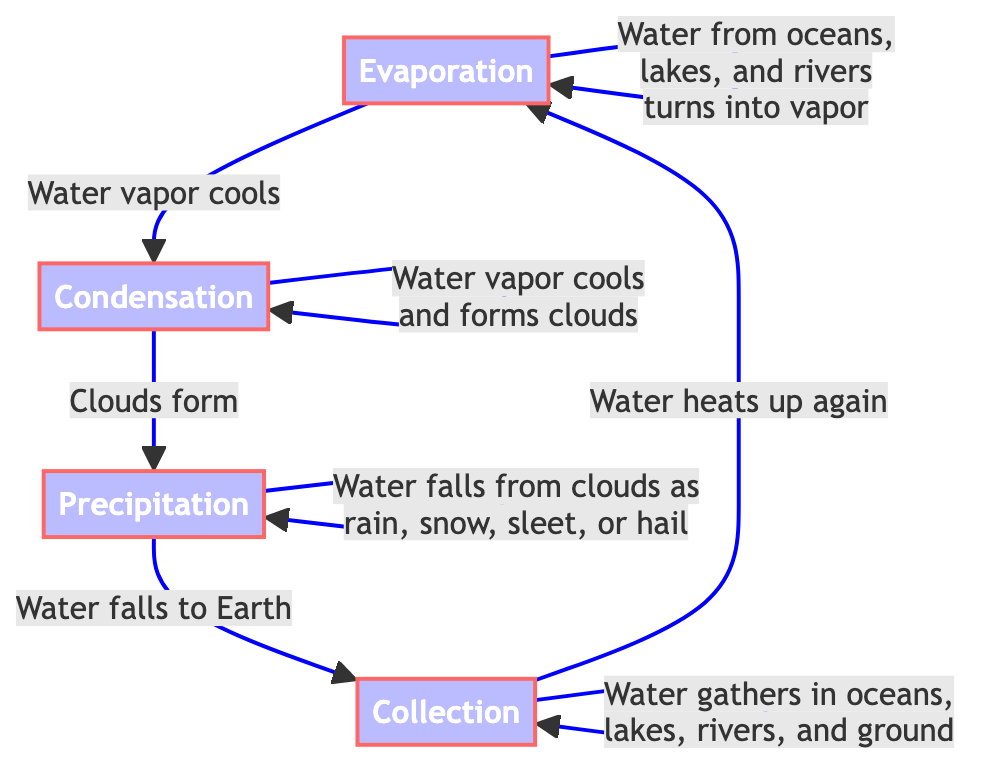What are the four stages of the water cycle shown in the diagram? The diagram explicitly lists four stages: Evaporation, Condensation, Precipitation, and Collection. Each stage is represented as a node in the flowchart.
Answer: Evaporation, Condensation, Precipitation, Collection What relationship is indicated between Evaporation and Condensation? The diagram shows an arrow from Evaporation to Condensation with the label "Water vapor cools," indicating that as water vapor cools, it transforms into condensate.
Answer: Water vapor cools How does water return to Earth in the water cycle? According to the diagram, water returns to Earth through the stage labeled Precipitation, where it falls from clouds. This can happen as rain, snow, sleet, or hail.
Answer: Precipitation What does the Collection stage represent in the water cycle? The diagram indicates that in the Collection stage, water gathers in oceans, lakes, rivers, and the ground, showing how water accumulates after falling to the Earth.
Answer: Water gathers in oceans, lakes, rivers, and ground Which stage directly follows Precipitation in the water cycle? The diagram shows that after the Precipitation stage, the next stage is Collection, indicating the flow of water after it falls to Earth.
Answer: Collection What processes are involved before the formation of clouds? The diagram illustrates that before clouds form, the water vapor must cool, which is indicated at the Condensation stage. Therefore, Evaporation leads to Condensation, which involves cooling.
Answer: Cooling of water vapor How many nodes are there in the water cycle diagram? The diagram contains four distinct nodes representing each stage of the water cycle: Evaporation, Condensation, Precipitation, and Collection, totaling four nodes.
Answer: Four What happens to water in the Collection stage according to the diagram? The Collection stage indicates that water gathers in various bodies of water, including oceans, lakes, rivers, and the ground, which concludes the cycle before it heats up again.
Answer: Water gathers in oceans, lakes, rivers, and ground What initiates the water cycle according to this diagram? This diagram specifies that the water cycle is initiated by Evaporation, where water from oceans, lakes, and rivers turns into vapor, indicating the start of the cycle.
Answer: Evaporation 